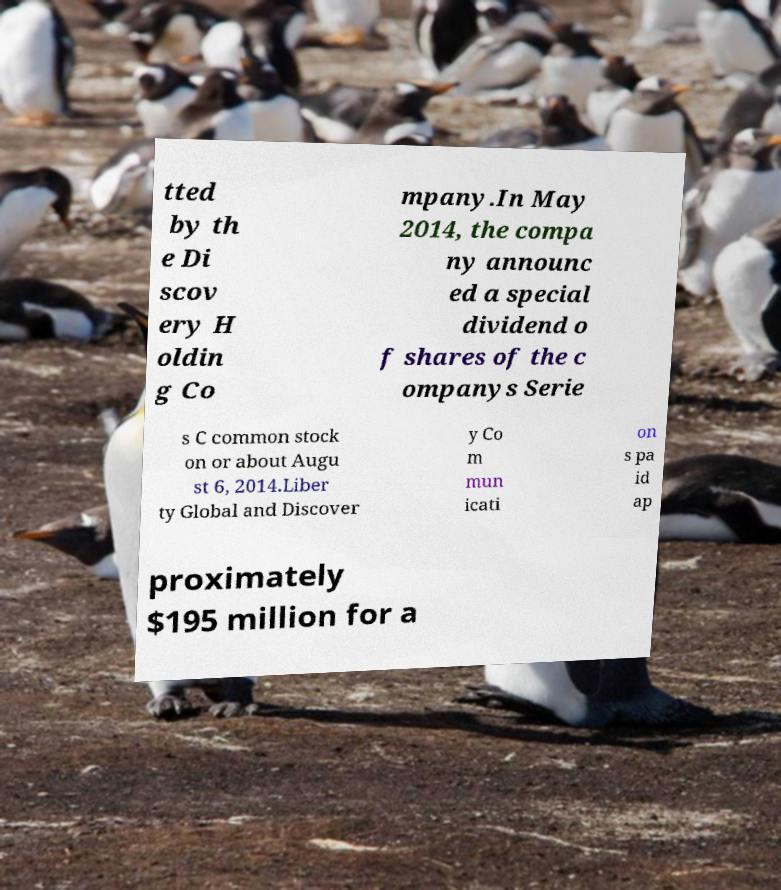Could you extract and type out the text from this image? tted by th e Di scov ery H oldin g Co mpany.In May 2014, the compa ny announc ed a special dividend o f shares of the c ompanys Serie s C common stock on or about Augu st 6, 2014.Liber ty Global and Discover y Co m mun icati on s pa id ap proximately $195 million for a 